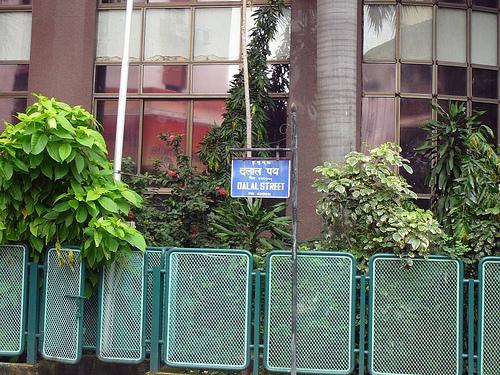What color is the sign?
Concise answer only. Blue. What is the name of this street?
Concise answer only. Dalal. Is that a building or a hotel?
Write a very short answer. Hotel. 